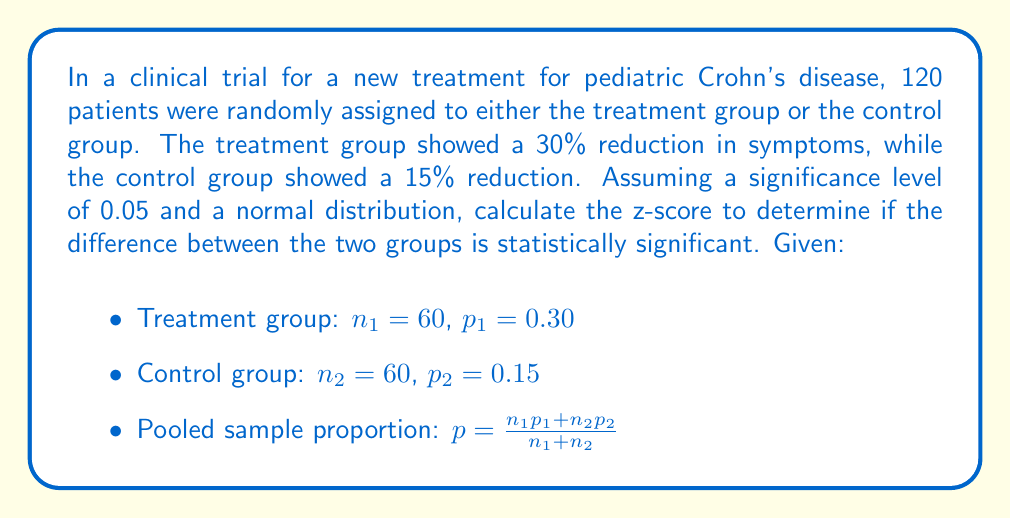Help me with this question. To determine if the difference between the two groups is statistically significant, we need to calculate the z-score using the formula for comparing two proportions:

$$z = \frac{p_1 - p_2}{\sqrt{p(1-p)(\frac{1}{n_1} + \frac{1}{n_2})}}$$

where $p$ is the pooled sample proportion.

Step 1: Calculate the pooled sample proportion $p$:
$$p = \frac{n_1p_1 + n_2p_2}{n_1 + n_2} = \frac{60(0.30) + 60(0.15)}{60 + 60} = \frac{18 + 9}{120} = \frac{27}{120} = 0.225$$

Step 2: Calculate the denominator of the z-score formula:
$$\sqrt{p(1-p)(\frac{1}{n_1} + \frac{1}{n_2})} = \sqrt{0.225(1-0.225)(\frac{1}{60} + \frac{1}{60})}$$
$$= \sqrt{0.225 \times 0.775 \times \frac{2}{60}} = \sqrt{0.005813} = 0.0762$$

Step 3: Calculate the z-score:
$$z = \frac{p_1 - p_2}{0.0762} = \frac{0.30 - 0.15}{0.0762} = \frac{0.15}{0.0762} = 1.97$$

The critical z-value for a two-tailed test at a significance level of 0.05 is ±1.96. Since our calculated z-score (1.97) is greater than 1.96, we can conclude that the difference between the treatment and control groups is statistically significant at the 0.05 level.
Answer: The z-score is 1.97, which is greater than the critical value of 1.96 for a significance level of 0.05. Therefore, the difference between the treatment and control groups is statistically significant. 